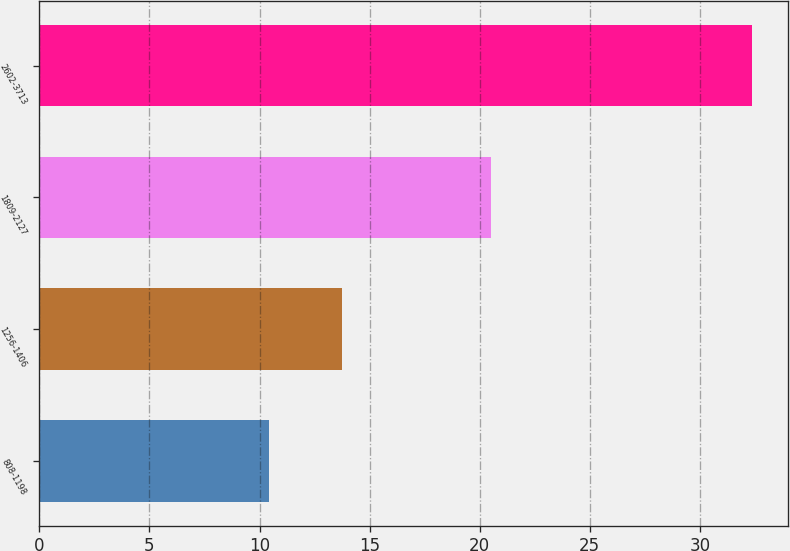<chart> <loc_0><loc_0><loc_500><loc_500><bar_chart><fcel>808-1198<fcel>1256-1406<fcel>1809-2127<fcel>2602-3713<nl><fcel>10.41<fcel>13.76<fcel>20.5<fcel>32.38<nl></chart> 